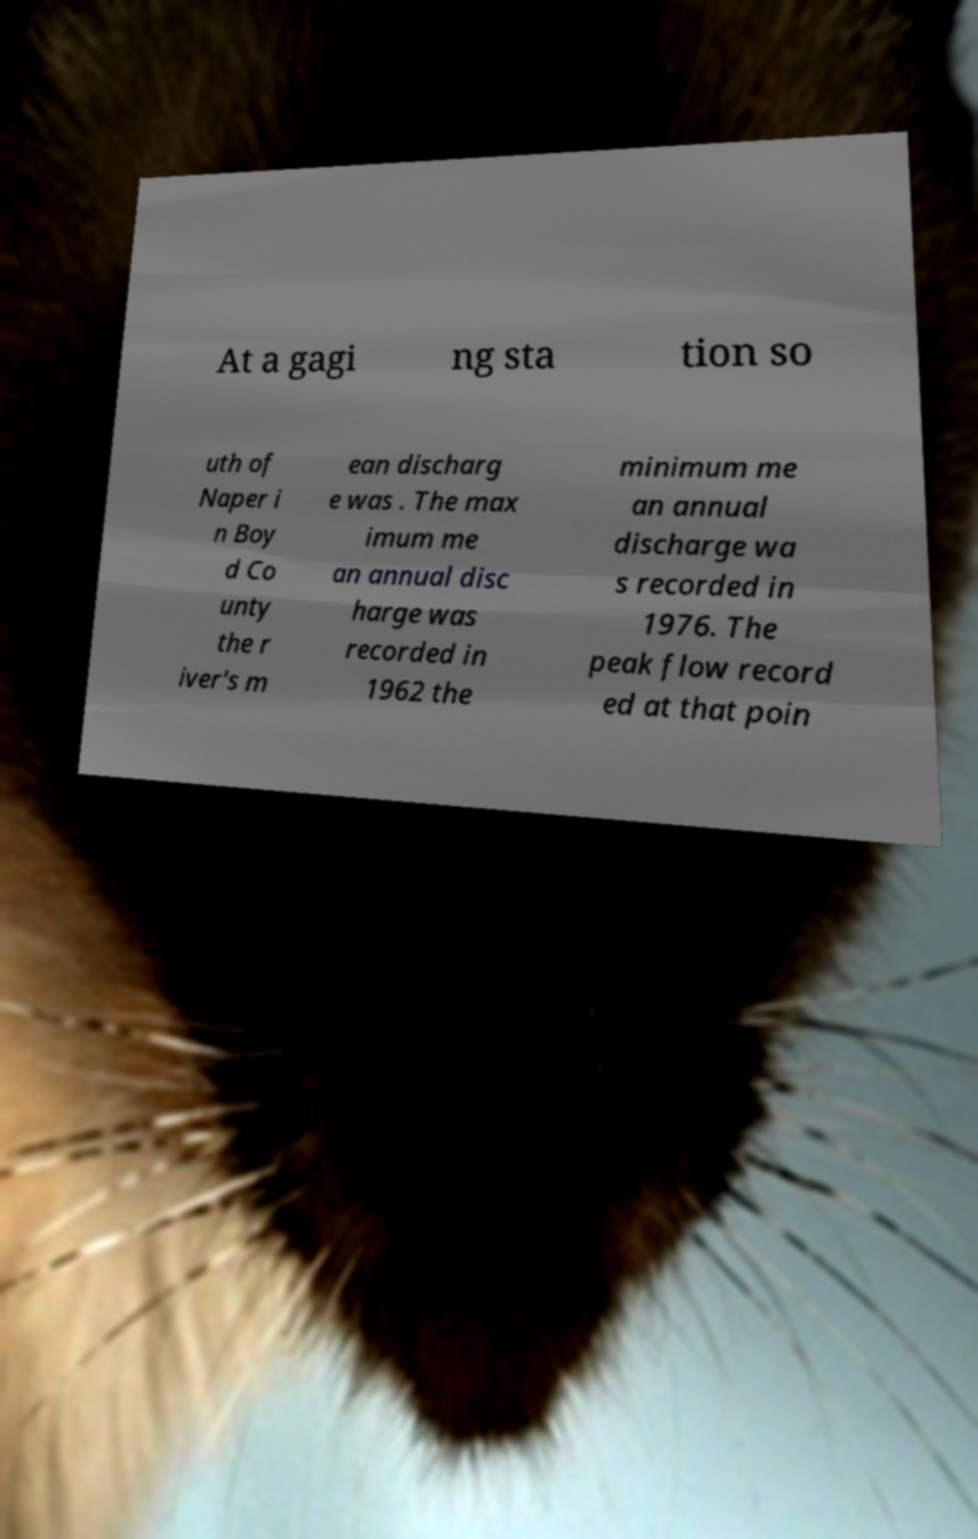I need the written content from this picture converted into text. Can you do that? At a gagi ng sta tion so uth of Naper i n Boy d Co unty the r iver's m ean discharg e was . The max imum me an annual disc harge was recorded in 1962 the minimum me an annual discharge wa s recorded in 1976. The peak flow record ed at that poin 